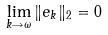<formula> <loc_0><loc_0><loc_500><loc_500>\lim _ { k \rightarrow \omega } \| e _ { k } \| _ { 2 } = 0</formula> 